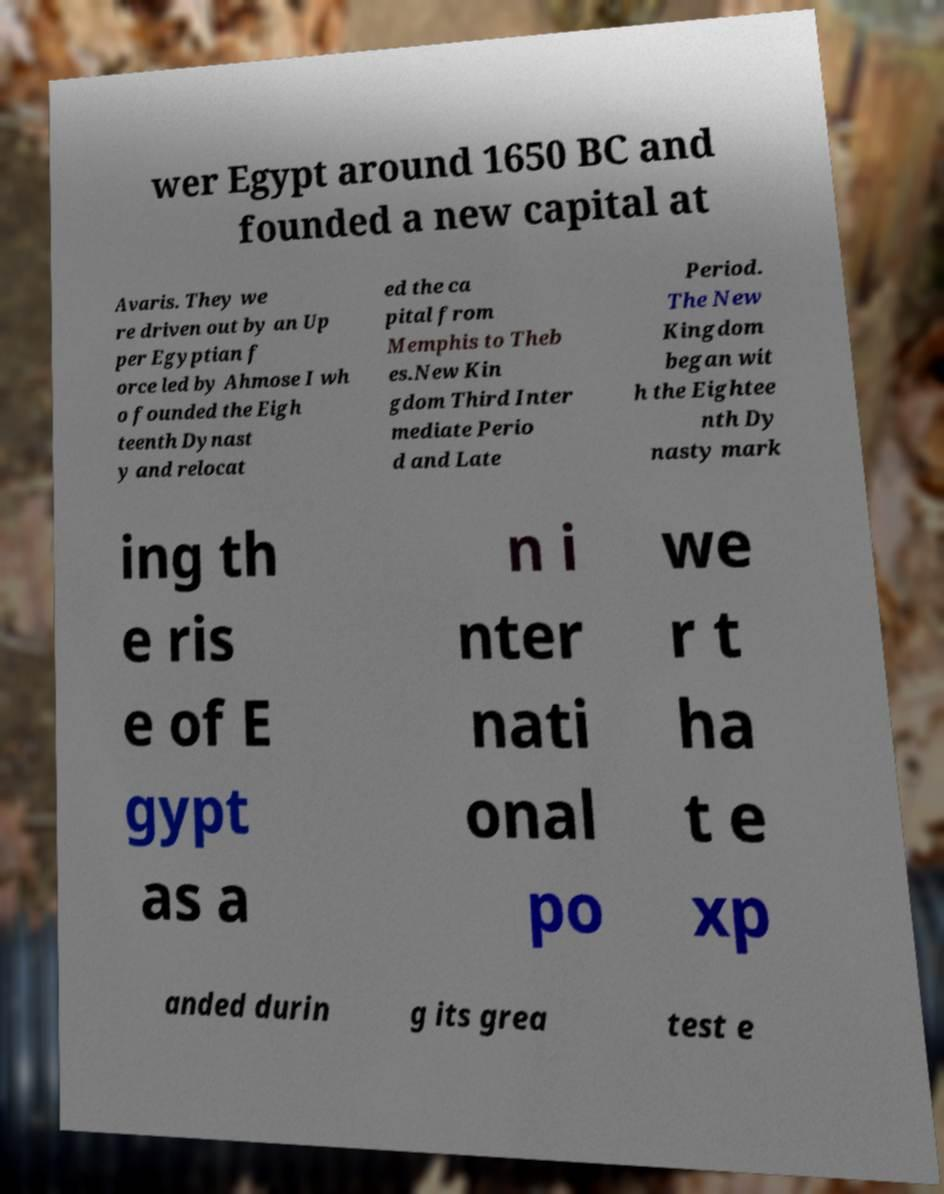What messages or text are displayed in this image? I need them in a readable, typed format. wer Egypt around 1650 BC and founded a new capital at Avaris. They we re driven out by an Up per Egyptian f orce led by Ahmose I wh o founded the Eigh teenth Dynast y and relocat ed the ca pital from Memphis to Theb es.New Kin gdom Third Inter mediate Perio d and Late Period. The New Kingdom began wit h the Eightee nth Dy nasty mark ing th e ris e of E gypt as a n i nter nati onal po we r t ha t e xp anded durin g its grea test e 